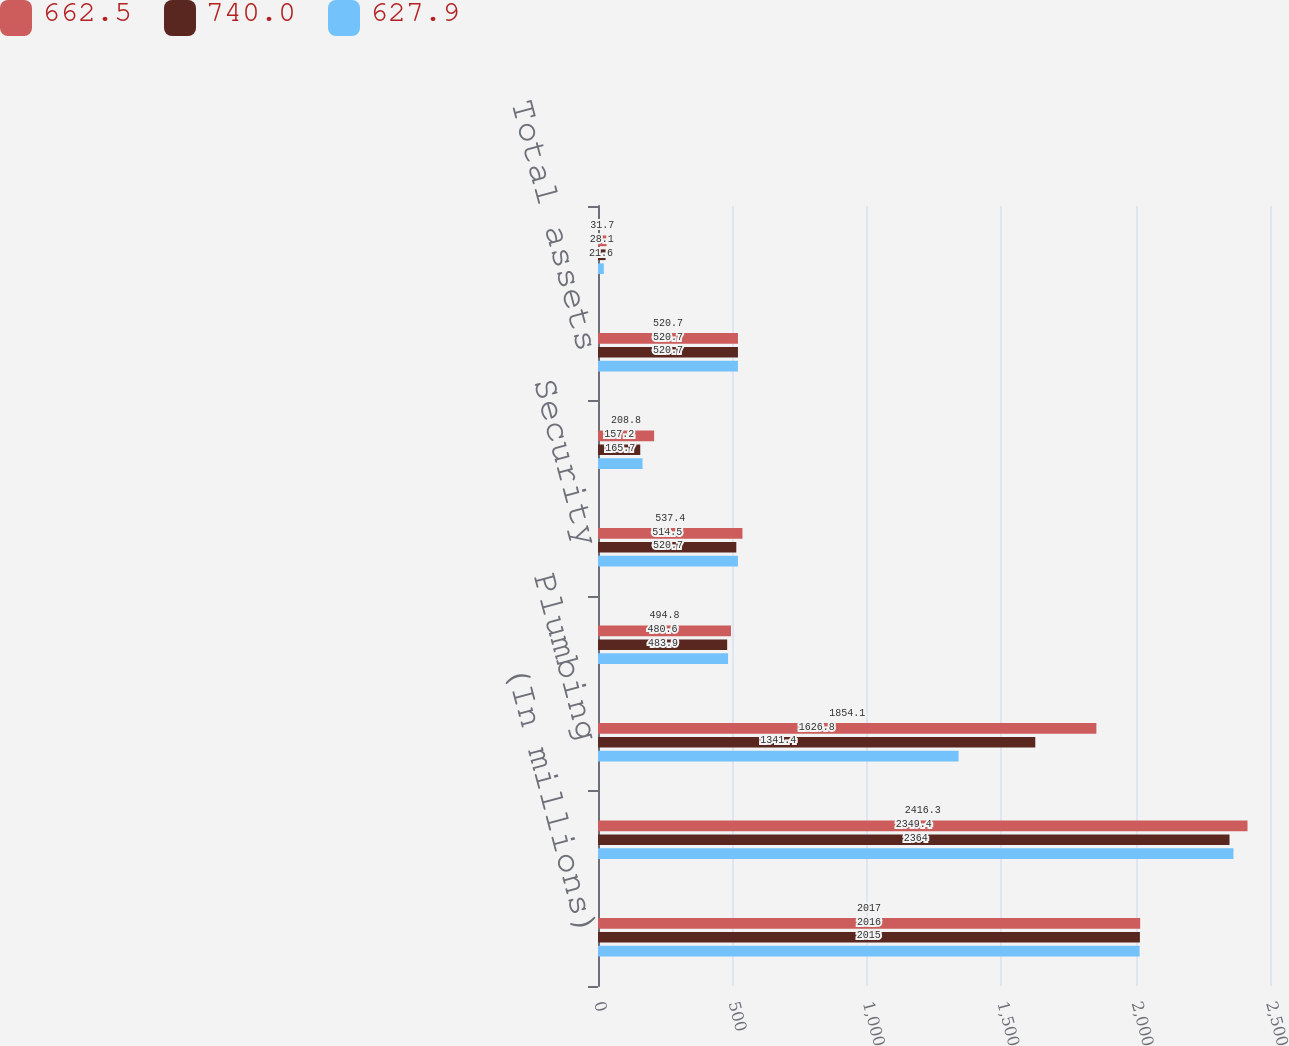Convert chart to OTSL. <chart><loc_0><loc_0><loc_500><loc_500><stacked_bar_chart><ecel><fcel>(In millions)<fcel>Cabinets<fcel>Plumbing<fcel>Doors<fcel>Security<fcel>Corporate<fcel>Total assets<fcel>Amortization of intangible<nl><fcel>662.5<fcel>2017<fcel>2416.3<fcel>1854.1<fcel>494.8<fcel>537.4<fcel>208.8<fcel>520.7<fcel>31.7<nl><fcel>740<fcel>2016<fcel>2349.4<fcel>1626.8<fcel>480.6<fcel>514.5<fcel>157.2<fcel>520.7<fcel>28.1<nl><fcel>627.9<fcel>2015<fcel>2364<fcel>1341.4<fcel>483.9<fcel>520.7<fcel>165.7<fcel>520.7<fcel>21.6<nl></chart> 